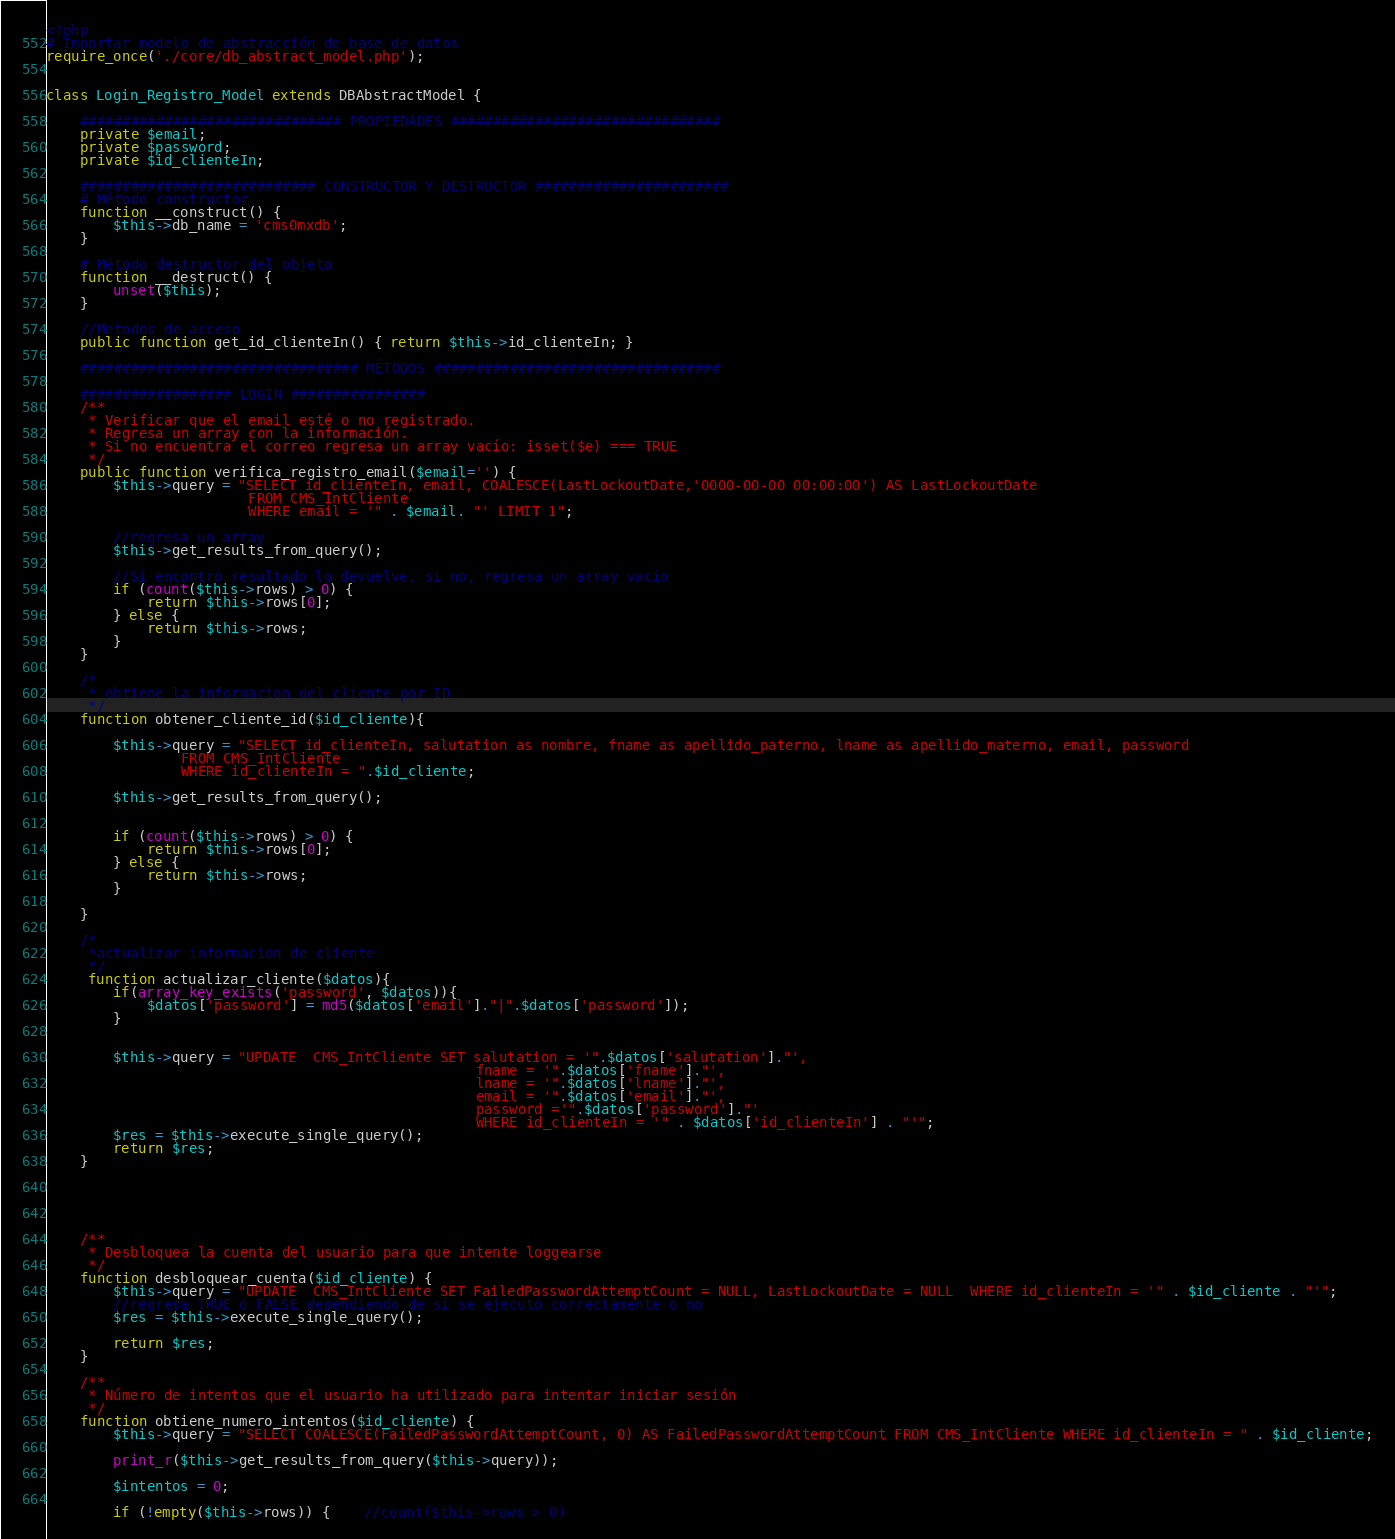Convert code to text. <code><loc_0><loc_0><loc_500><loc_500><_PHP_><?php
# Importar modelo de abstracción de base de datos 
require_once('./core/db_abstract_model.php');


class Login_Registro_Model extends DBAbstractModel {

    ############################### PROPIEDADES ################################
    private $email;
	private $password;	
    private $id_clienteIn;

	############################ CONSTRUCTOR Y DESTRUCTOR #######################
    # Método constructor
    function __construct() {
		$this->db_name = 'cms0mxdb';
    }

    # Método destructor del objeto
    function __destruct() {
        unset($this);
    }
			
	//Metodos de acceso
	public function get_id_clienteIn() { return $this->id_clienteIn; }
		
    ################################# MÉTODOS ##################################
    
    ################## LOGIN ################
    /**
	 * Verificar que el email esté o no registrado.
	 * Regresa un array con la información.
	 * Si no encuentra el correo regresa un array vacío: isset($e) === TRUE
	 */
    public function verifica_registro_email($email='') {    	
		$this->query = "SELECT id_clienteIn, email, COALESCE(LastLockoutDate,'0000-00-00 00:00:00') AS LastLockoutDate 
						FROM CMS_IntCliente
						WHERE email = '" . $email. "' LIMIT 1";

		//regresa un array
		$this->get_results_from_query();
		
		//Si encontró resultado lo devuelve, si no, regresa un array vacío
		if (count($this->rows) > 0) {
			return $this->rows[0];
		} else {
			return $this->rows;
		}
	}
	
	/*
	 * obtiene la informacion del cliente por ID
	 */ 
    function obtener_cliente_id($id_cliente){
							
		$this->query = "SELECT id_clienteIn, salutation as nombre, fname as apellido_paterno, lname as apellido_materno, email, password  
				FROM CMS_IntCliente
				WHERE id_clienteIn = ".$id_cliente;
				
		$this->get_results_from_query();
		
			
		if (count($this->rows) > 0) {
			return $this->rows[0];
		} else {			
			return $this->rows;
		}
							
	}
	
	/*
	 *actualizar informacion de cliente 
	 */
	 function actualizar_cliente($datos){
		if(array_key_exists('password', $datos)){
			$datos['password'] = md5($datos['email']."|".$datos['password']);	
		}
				
		
		$this->query = "UPDATE  CMS_IntCliente SET salutation = '".$datos['salutation']."',
												   fname = '".$datos['fname']."',
												   lname = '".$datos['lname']."',
												   email = '".$datos['email']."',
												   password ='".$datos['password']."'	 
		                                           WHERE id_clienteIn = '" . $datos['id_clienteIn'] . "'";
		$res = $this->execute_single_query();
		return $res;		
	}
	 
	 
	   
	 
	  
	/**
	 * Desbloquea la cuenta del usuario para que intente loggearse
	 */
	function desbloquear_cuenta($id_cliente) {								
		$this->query = "UPDATE  CMS_IntCliente SET FailedPasswordAttemptCount = NULL, LastLockoutDate = NULL  WHERE id_clienteIn = '" . $id_cliente . "'";
		//regresa TRUE ó FALSE dependiendo de si se ejecutó correctamente o no 
		$res = $this->execute_single_query();
		
		return $res;				
	}
    
    /**
	 * Número de intentos que el usuario ha utilizado para intentar iniciar sesión
	 */
	function obtiene_numero_intentos($id_cliente) {
		$this->query = "SELECT COALESCE(FailedPasswordAttemptCount, 0) AS FailedPasswordAttemptCount FROM CMS_IntCliente WHERE id_clienteIn = " . $id_cliente;
		
		print_r($this->get_results_from_query($this->query));
		
		$intentos = 0;
		
		if (!empty($this->rows)) {	//count($this->rows > 0)</code> 